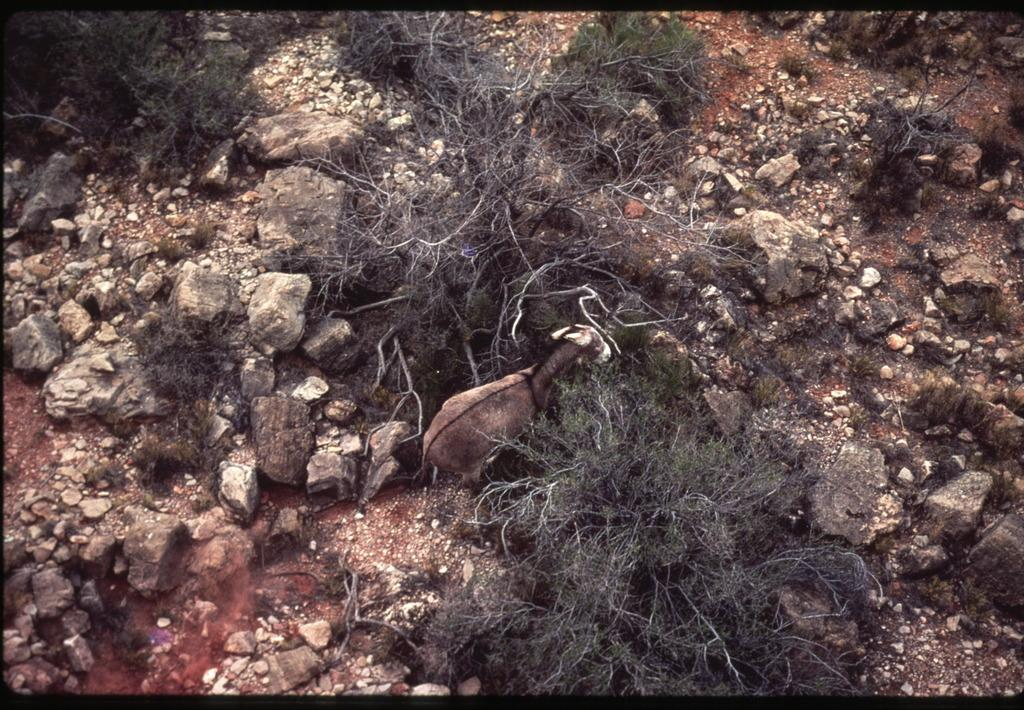What type of living organisms can be seen in the image? Plants can be seen in the image. What other objects are present in the image? There are stones in the image. Are there any animals visible in the image? Yes, there is an animal in the image. What type of lace can be seen on the animal in the image? There is no lace present on the animal in the image. Can you hear the voice of the animal in the image? The image is silent, so it is not possible to hear the voice of the animal. 